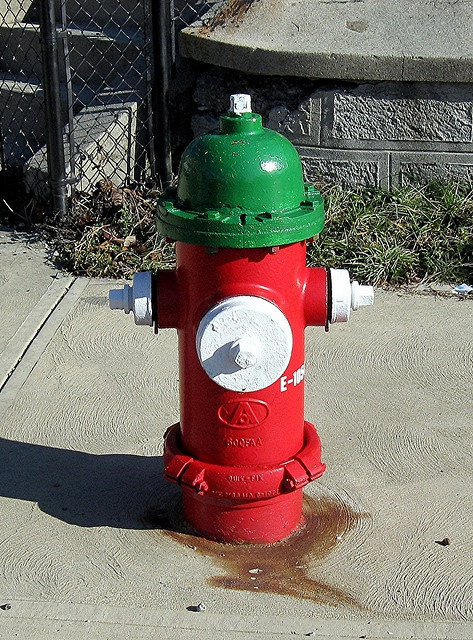Describe the objects in this image and their specific colors. I can see a fire hydrant in darkgray, maroon, black, red, and white tones in this image. 